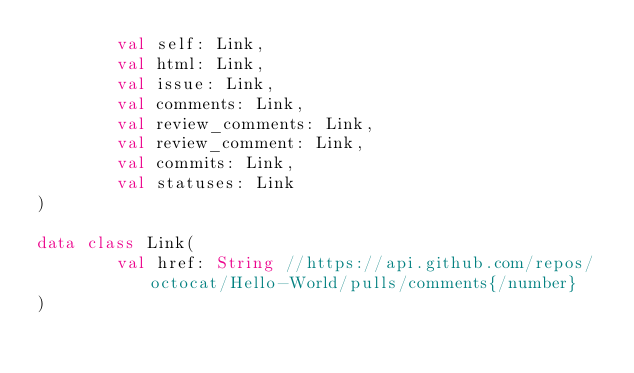<code> <loc_0><loc_0><loc_500><loc_500><_Kotlin_>        val self: Link,
        val html: Link,
        val issue: Link,
        val comments: Link,
        val review_comments: Link,
        val review_comment: Link,
        val commits: Link,
        val statuses: Link
)

data class Link(
        val href: String //https://api.github.com/repos/octocat/Hello-World/pulls/comments{/number}
)</code> 